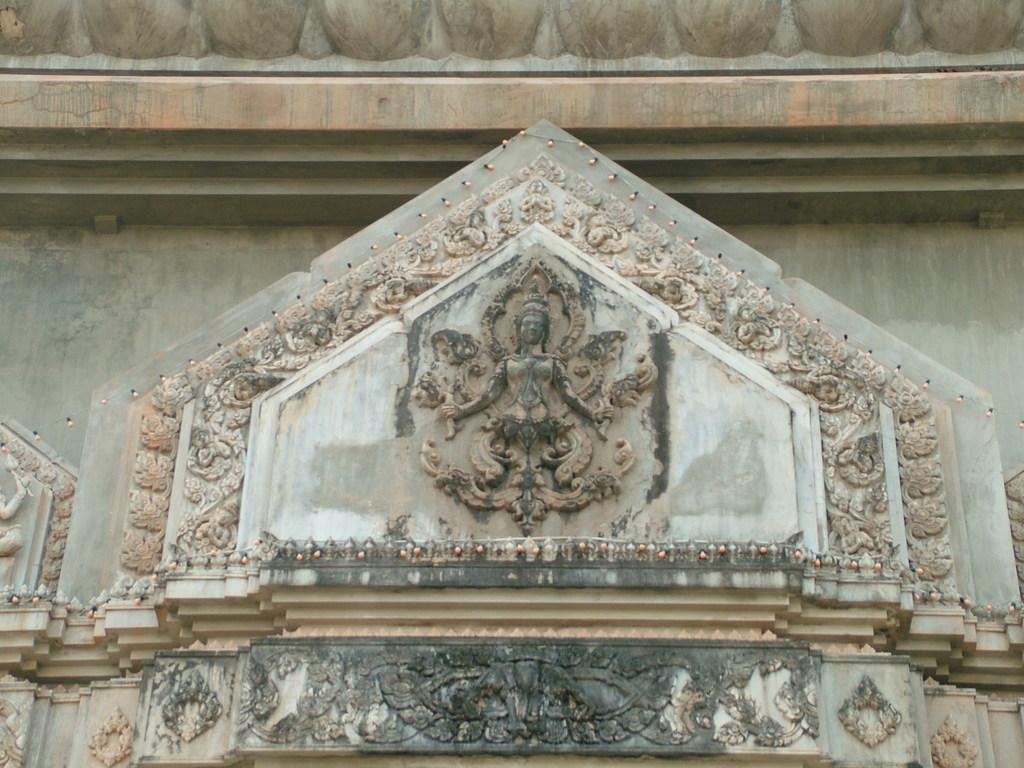What is the main subject of the image? The main subject of the image is a statue. Where is the statue located? The statue is carved on the front part of a building. How many kittens are sitting on the statue in the image? There are no kittens present in the image; the statue is on the front part of a building. What type of meat is being served on the statue in the image? There is no meat present in the image; the statue is on the front part of a building. 